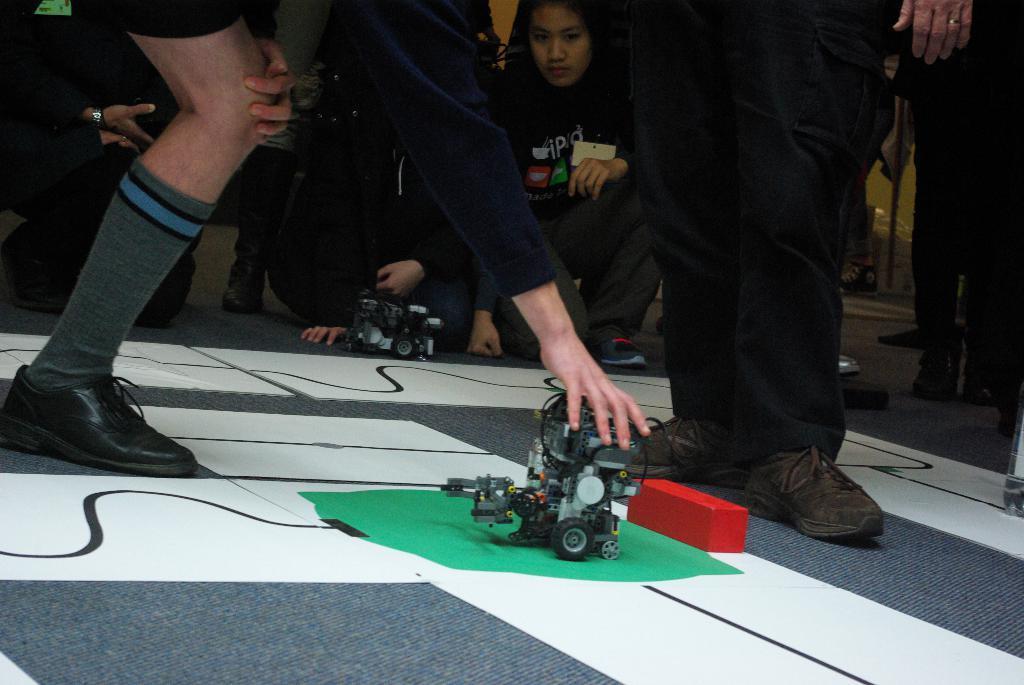In one or two sentences, can you explain what this image depicts? In this image I can see in the middle, there is an electronic vehicle and a person is holding it. At the top there is a person standing and looking at this vehicle. 